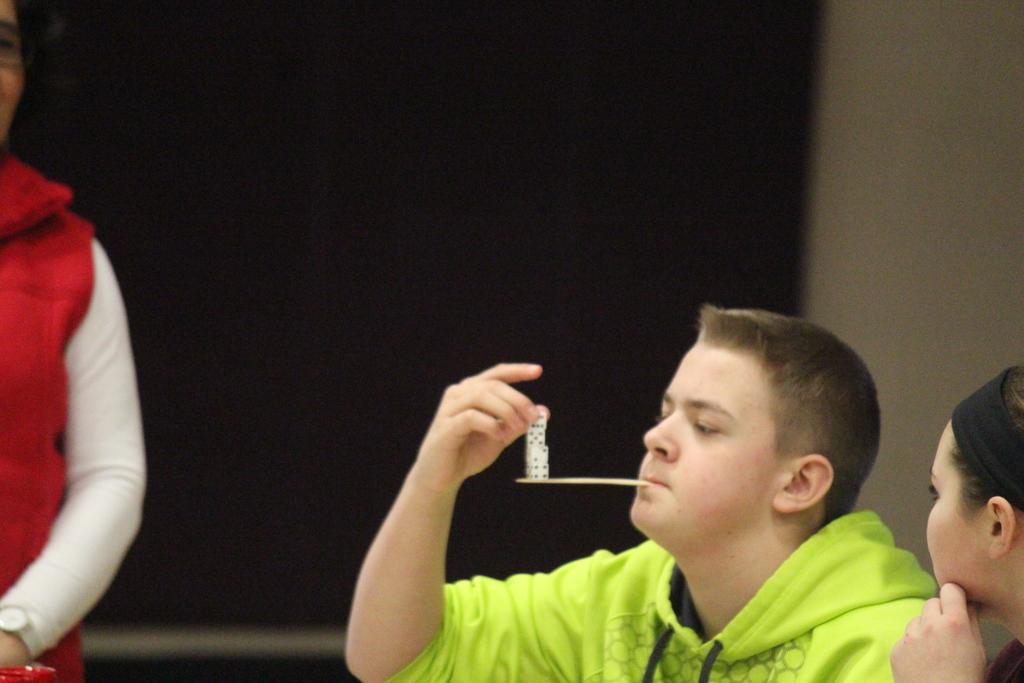Can you describe this image briefly? In this image I can see a person wearing green colored dress is holding a die in his hand and a stick in his mouth. I can see few other persons and in the background I can see the black colored surface. 